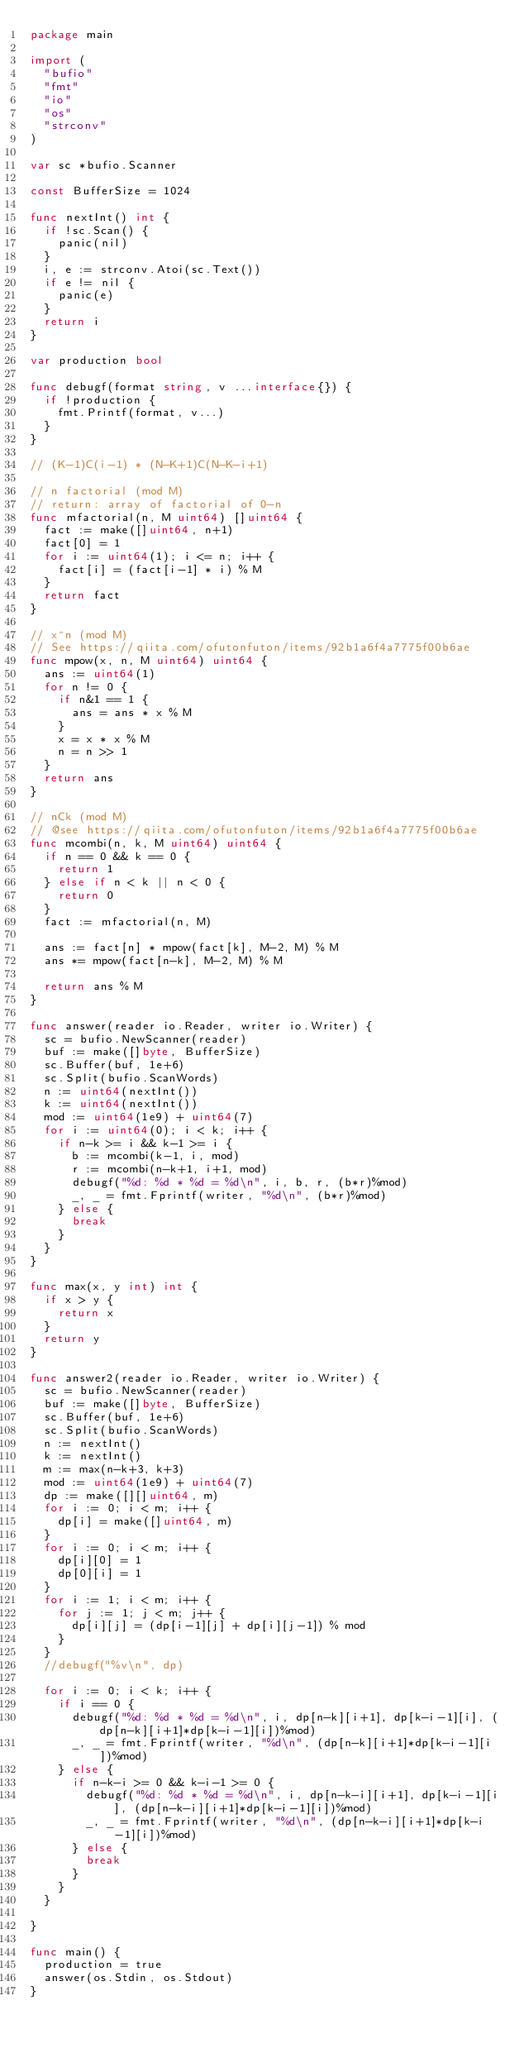Convert code to text. <code><loc_0><loc_0><loc_500><loc_500><_Go_>package main

import (
	"bufio"
	"fmt"
	"io"
	"os"
	"strconv"
)

var sc *bufio.Scanner

const BufferSize = 1024

func nextInt() int {
	if !sc.Scan() {
		panic(nil)
	}
	i, e := strconv.Atoi(sc.Text())
	if e != nil {
		panic(e)
	}
	return i
}

var production bool

func debugf(format string, v ...interface{}) {
	if !production {
		fmt.Printf(format, v...)
	}
}

// (K-1)C(i-1) * (N-K+1)C(N-K-i+1)

// n factorial (mod M)
// return: array of factorial of 0-n
func mfactorial(n, M uint64) []uint64 {
	fact := make([]uint64, n+1)
	fact[0] = 1
	for i := uint64(1); i <= n; i++ {
		fact[i] = (fact[i-1] * i) % M
	}
	return fact
}

// x^n (mod M)
// See https://qiita.com/ofutonfuton/items/92b1a6f4a7775f00b6ae
func mpow(x, n, M uint64) uint64 {
	ans := uint64(1)
	for n != 0 {
		if n&1 == 1 {
			ans = ans * x % M
		}
		x = x * x % M
		n = n >> 1
	}
	return ans
}

// nCk (mod M)
// @see https://qiita.com/ofutonfuton/items/92b1a6f4a7775f00b6ae
func mcombi(n, k, M uint64) uint64 {
	if n == 0 && k == 0 {
		return 1
	} else if n < k || n < 0 {
		return 0
	}
	fact := mfactorial(n, M)

	ans := fact[n] * mpow(fact[k], M-2, M) % M
	ans *= mpow(fact[n-k], M-2, M) % M

	return ans % M
}

func answer(reader io.Reader, writer io.Writer) {
	sc = bufio.NewScanner(reader)
	buf := make([]byte, BufferSize)
	sc.Buffer(buf, 1e+6)
	sc.Split(bufio.ScanWords)
	n := uint64(nextInt())
	k := uint64(nextInt())
	mod := uint64(1e9) + uint64(7)
	for i := uint64(0); i < k; i++ {
		if n-k >= i && k-1 >= i {
			b := mcombi(k-1, i, mod)
			r := mcombi(n-k+1, i+1, mod)
			debugf("%d: %d * %d = %d\n", i, b, r, (b*r)%mod)
			_, _ = fmt.Fprintf(writer, "%d\n", (b*r)%mod)
		} else {
			break
		}
	}
}

func max(x, y int) int {
	if x > y {
		return x
	}
	return y
}

func answer2(reader io.Reader, writer io.Writer) {
	sc = bufio.NewScanner(reader)
	buf := make([]byte, BufferSize)
	sc.Buffer(buf, 1e+6)
	sc.Split(bufio.ScanWords)
	n := nextInt()
	k := nextInt()
	m := max(n-k+3, k+3)
	mod := uint64(1e9) + uint64(7)
	dp := make([][]uint64, m)
	for i := 0; i < m; i++ {
		dp[i] = make([]uint64, m)
	}
	for i := 0; i < m; i++ {
		dp[i][0] = 1
		dp[0][i] = 1
	}
	for i := 1; i < m; i++ {
		for j := 1; j < m; j++ {
			dp[i][j] = (dp[i-1][j] + dp[i][j-1]) % mod
		}
	}
	//debugf("%v\n", dp)

	for i := 0; i < k; i++ {
		if i == 0 {
			debugf("%d: %d * %d = %d\n", i, dp[n-k][i+1], dp[k-i-1][i], (dp[n-k][i+1]*dp[k-i-1][i])%mod)
			_, _ = fmt.Fprintf(writer, "%d\n", (dp[n-k][i+1]*dp[k-i-1][i])%mod)
		} else {
			if n-k-i >= 0 && k-i-1 >= 0 {
				debugf("%d: %d * %d = %d\n", i, dp[n-k-i][i+1], dp[k-i-1][i], (dp[n-k-i][i+1]*dp[k-i-1][i])%mod)
				_, _ = fmt.Fprintf(writer, "%d\n", (dp[n-k-i][i+1]*dp[k-i-1][i])%mod)
			} else {
				break
			}
		}
	}

}

func main() {
	production = true
	answer(os.Stdin, os.Stdout)
}
</code> 